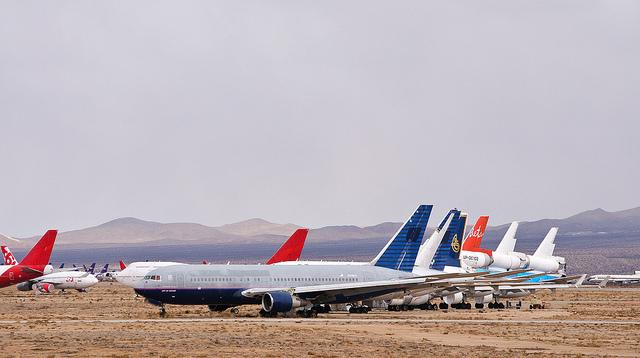What is the blue back piece of the plane called?

Choices:
A) fuselage
B) rotor
C) tail pipe
D) fin fin 